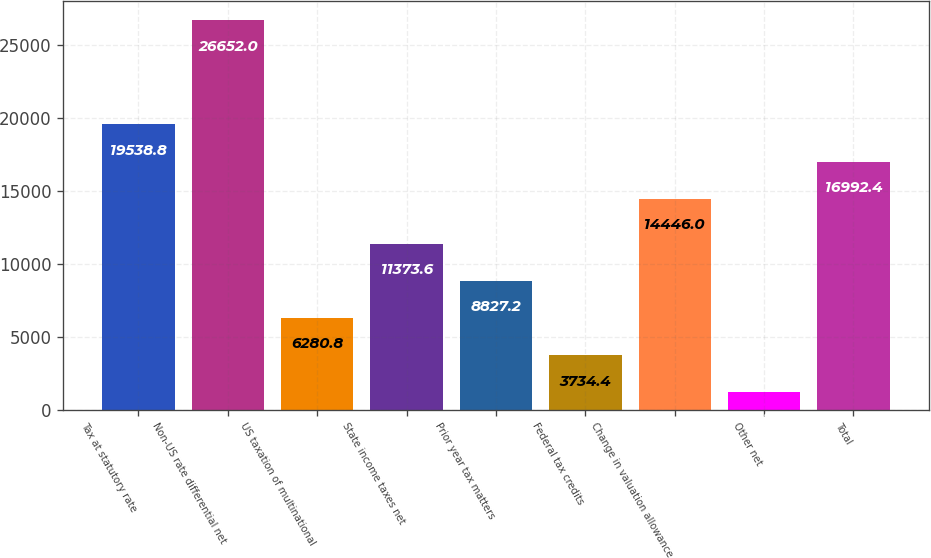<chart> <loc_0><loc_0><loc_500><loc_500><bar_chart><fcel>Tax at statutory rate<fcel>Non-US rate differential net<fcel>US taxation of multinational<fcel>State income taxes net<fcel>Prior year tax matters<fcel>Federal tax credits<fcel>Change in valuation allowance<fcel>Other net<fcel>Total<nl><fcel>19538.8<fcel>26652<fcel>6280.8<fcel>11373.6<fcel>8827.2<fcel>3734.4<fcel>14446<fcel>1188<fcel>16992.4<nl></chart> 